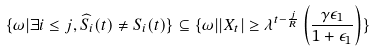<formula> <loc_0><loc_0><loc_500><loc_500>\{ \omega | \exists i \leq j , \widehat { S } _ { i } ( t ) \neq S _ { i } ( t ) \} \subseteq \{ \omega | | X _ { t } | \geq \lambda ^ { t - \frac { j } { R } } \left ( \frac { \gamma \epsilon _ { 1 } } { 1 + \epsilon _ { 1 } } \right ) \}</formula> 